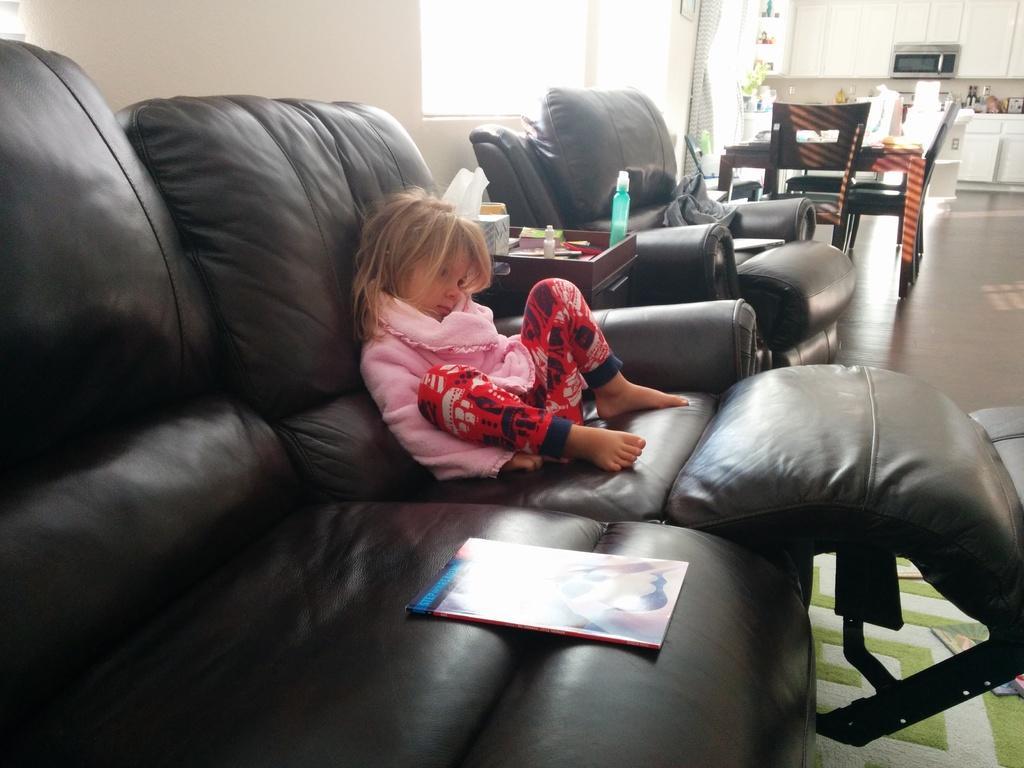Could you give a brief overview of what you see in this image? Here is a kid who is wearing pink color top and red color bottom, she is sitting on a sofa which is of black color and there is a book beside her, to the right side of the kid there is a table and there are some utilities on the table and beside the table there is another sofa and beside the sofa there is dining table and a oven, there are also few cupboards beside this oven. In the background there is a wall and beside the wall there is a window and beside that there is a curtain. 